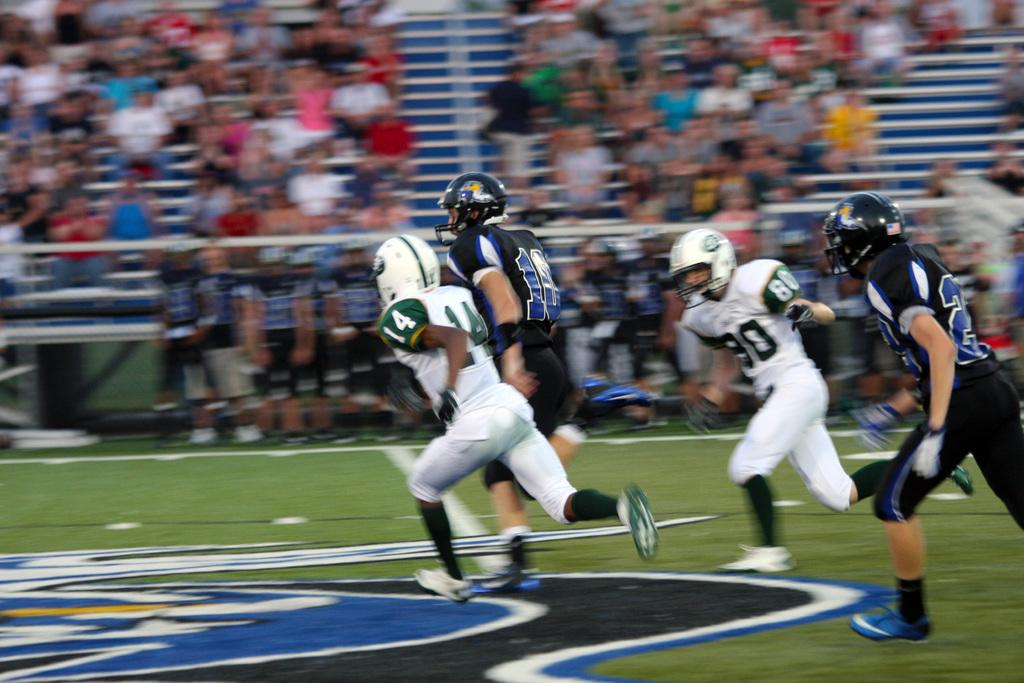What are the people in the image wearing? The people in the image are wearing sports uniforms. What are the people with sports uniforms doing? They are playing in a ground. What can be seen in the background of the image? In the background, there are people standing and people sitting on benches. What rhythm can be heard from the people playing in the image? There is no sound or rhythm present in the image, as it is a still photograph. 